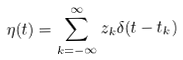<formula> <loc_0><loc_0><loc_500><loc_500>\eta ( t ) = \sum _ { k = - \infty } ^ { \infty } z _ { k } \delta ( t - t _ { k } )</formula> 